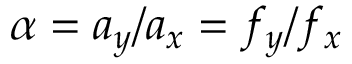Convert formula to latex. <formula><loc_0><loc_0><loc_500><loc_500>\alpha = a _ { y } / a _ { x } = f _ { y } / f _ { x }</formula> 